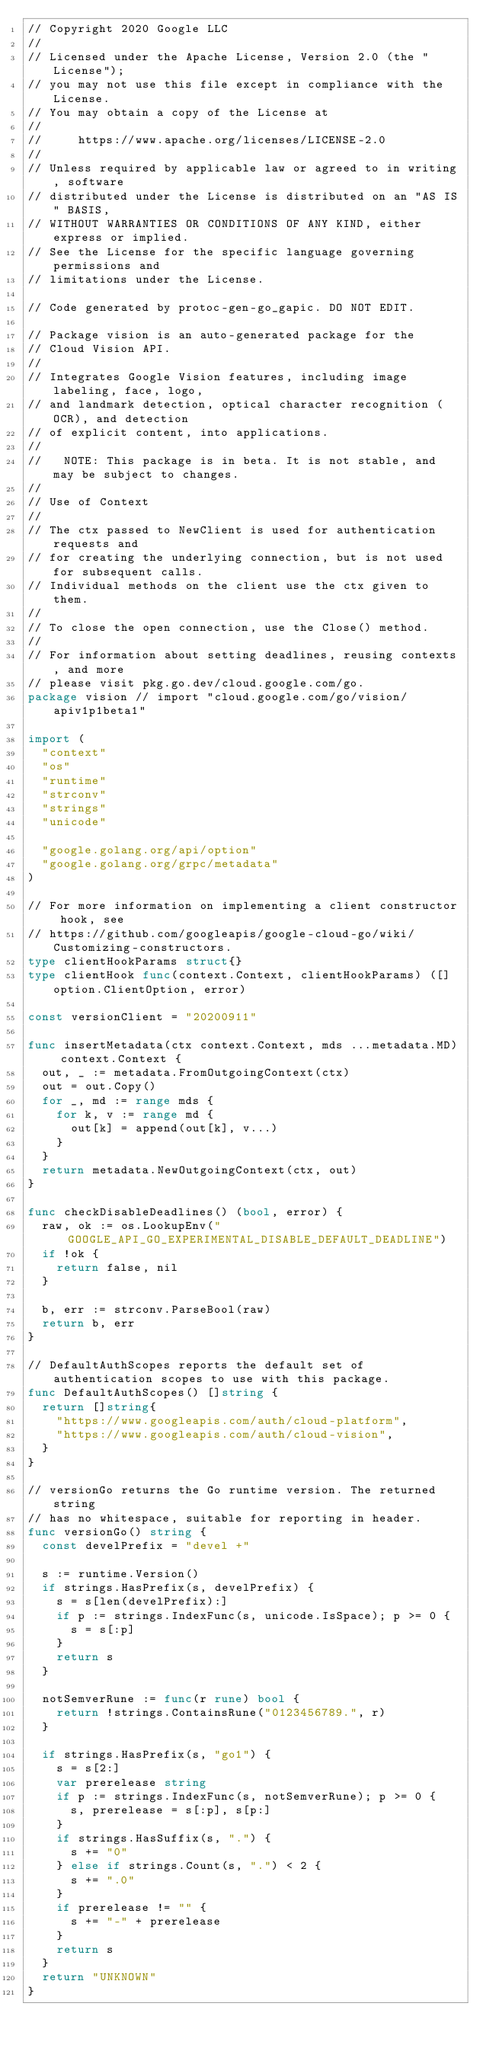Convert code to text. <code><loc_0><loc_0><loc_500><loc_500><_Go_>// Copyright 2020 Google LLC
//
// Licensed under the Apache License, Version 2.0 (the "License");
// you may not use this file except in compliance with the License.
// You may obtain a copy of the License at
//
//     https://www.apache.org/licenses/LICENSE-2.0
//
// Unless required by applicable law or agreed to in writing, software
// distributed under the License is distributed on an "AS IS" BASIS,
// WITHOUT WARRANTIES OR CONDITIONS OF ANY KIND, either express or implied.
// See the License for the specific language governing permissions and
// limitations under the License.

// Code generated by protoc-gen-go_gapic. DO NOT EDIT.

// Package vision is an auto-generated package for the
// Cloud Vision API.
//
// Integrates Google Vision features, including image labeling, face, logo,
// and landmark detection, optical character recognition (OCR), and detection
// of explicit content, into applications.
//
//   NOTE: This package is in beta. It is not stable, and may be subject to changes.
//
// Use of Context
//
// The ctx passed to NewClient is used for authentication requests and
// for creating the underlying connection, but is not used for subsequent calls.
// Individual methods on the client use the ctx given to them.
//
// To close the open connection, use the Close() method.
//
// For information about setting deadlines, reusing contexts, and more
// please visit pkg.go.dev/cloud.google.com/go.
package vision // import "cloud.google.com/go/vision/apiv1p1beta1"

import (
	"context"
	"os"
	"runtime"
	"strconv"
	"strings"
	"unicode"

	"google.golang.org/api/option"
	"google.golang.org/grpc/metadata"
)

// For more information on implementing a client constructor hook, see
// https://github.com/googleapis/google-cloud-go/wiki/Customizing-constructors.
type clientHookParams struct{}
type clientHook func(context.Context, clientHookParams) ([]option.ClientOption, error)

const versionClient = "20200911"

func insertMetadata(ctx context.Context, mds ...metadata.MD) context.Context {
	out, _ := metadata.FromOutgoingContext(ctx)
	out = out.Copy()
	for _, md := range mds {
		for k, v := range md {
			out[k] = append(out[k], v...)
		}
	}
	return metadata.NewOutgoingContext(ctx, out)
}

func checkDisableDeadlines() (bool, error) {
	raw, ok := os.LookupEnv("GOOGLE_API_GO_EXPERIMENTAL_DISABLE_DEFAULT_DEADLINE")
	if !ok {
		return false, nil
	}

	b, err := strconv.ParseBool(raw)
	return b, err
}

// DefaultAuthScopes reports the default set of authentication scopes to use with this package.
func DefaultAuthScopes() []string {
	return []string{
		"https://www.googleapis.com/auth/cloud-platform",
		"https://www.googleapis.com/auth/cloud-vision",
	}
}

// versionGo returns the Go runtime version. The returned string
// has no whitespace, suitable for reporting in header.
func versionGo() string {
	const develPrefix = "devel +"

	s := runtime.Version()
	if strings.HasPrefix(s, develPrefix) {
		s = s[len(develPrefix):]
		if p := strings.IndexFunc(s, unicode.IsSpace); p >= 0 {
			s = s[:p]
		}
		return s
	}

	notSemverRune := func(r rune) bool {
		return !strings.ContainsRune("0123456789.", r)
	}

	if strings.HasPrefix(s, "go1") {
		s = s[2:]
		var prerelease string
		if p := strings.IndexFunc(s, notSemverRune); p >= 0 {
			s, prerelease = s[:p], s[p:]
		}
		if strings.HasSuffix(s, ".") {
			s += "0"
		} else if strings.Count(s, ".") < 2 {
			s += ".0"
		}
		if prerelease != "" {
			s += "-" + prerelease
		}
		return s
	}
	return "UNKNOWN"
}
</code> 